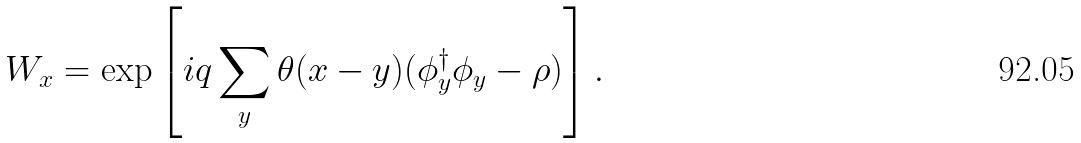Convert formula to latex. <formula><loc_0><loc_0><loc_500><loc_500>W _ { x } = \exp \left [ i q \sum _ { y } \theta ( x - y ) ( \phi ^ { \dagger } _ { y } \phi _ { y } - \rho ) \right ] .</formula> 